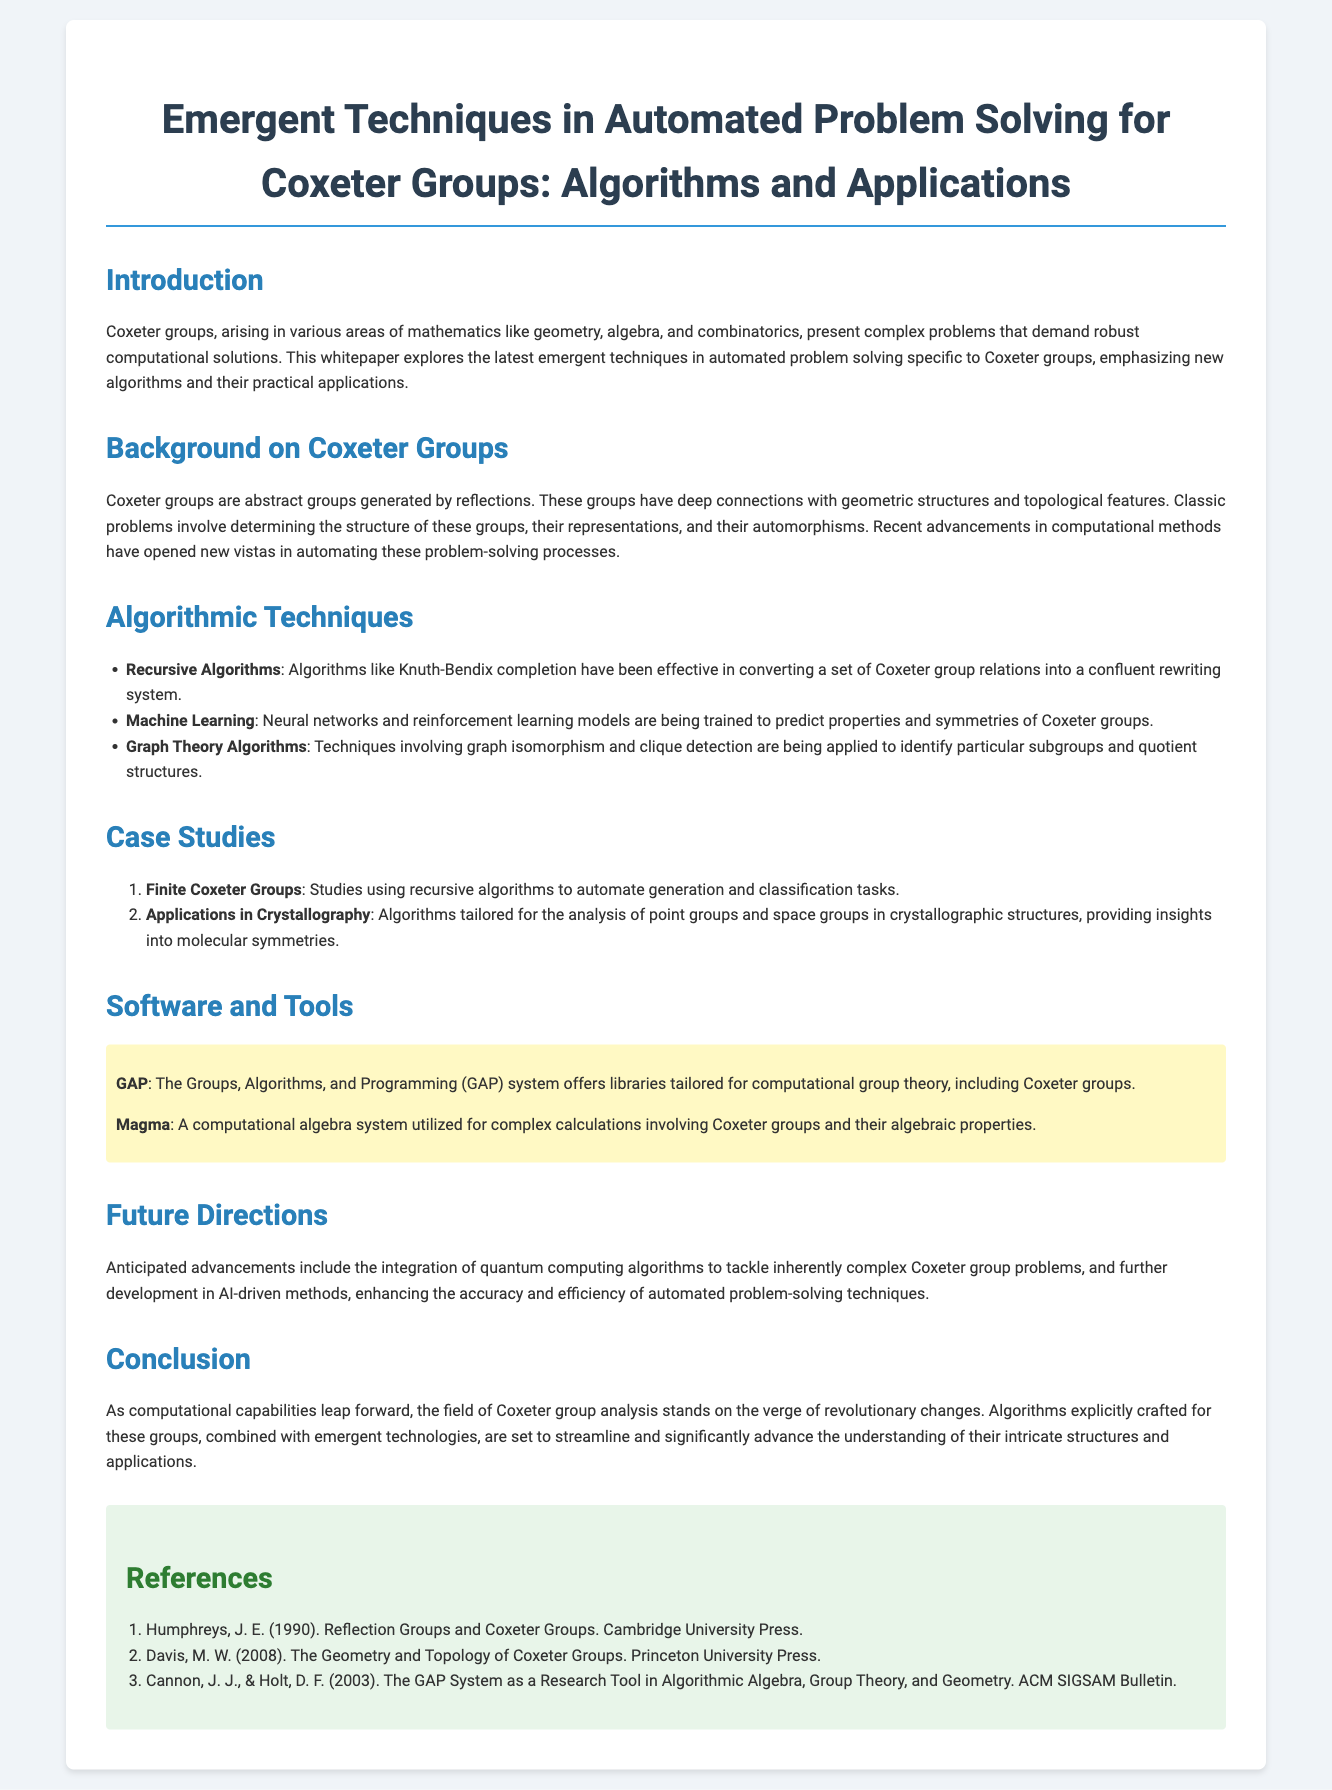What are Coxeter groups? Coxeter groups are abstract groups generated by reflections and have connections with geometric structures and topological features.
Answer: Abstract groups generated by reflections What is one application of algorithms in crystallography? Algorithms in crystallography are tailored for analyzing point groups and space groups, providing insights into molecular symmetries.
Answer: Analyzing point groups Which algorithm is described as effective for Coxeter group relations? The Knuth-Bendix completion algorithm is effective in converting a set of Coxeter group relations into a confluent rewriting system.
Answer: Knuth-Bendix completion What does the GAP system offer? The GAP system offers libraries tailored for computational group theory, including Coxeter groups.
Answer: Libraries for computational group theory What future advancement is anticipated for Coxeter group problems? Anticipated advancements include the integration of quantum computing algorithms.
Answer: Quantum computing algorithms 